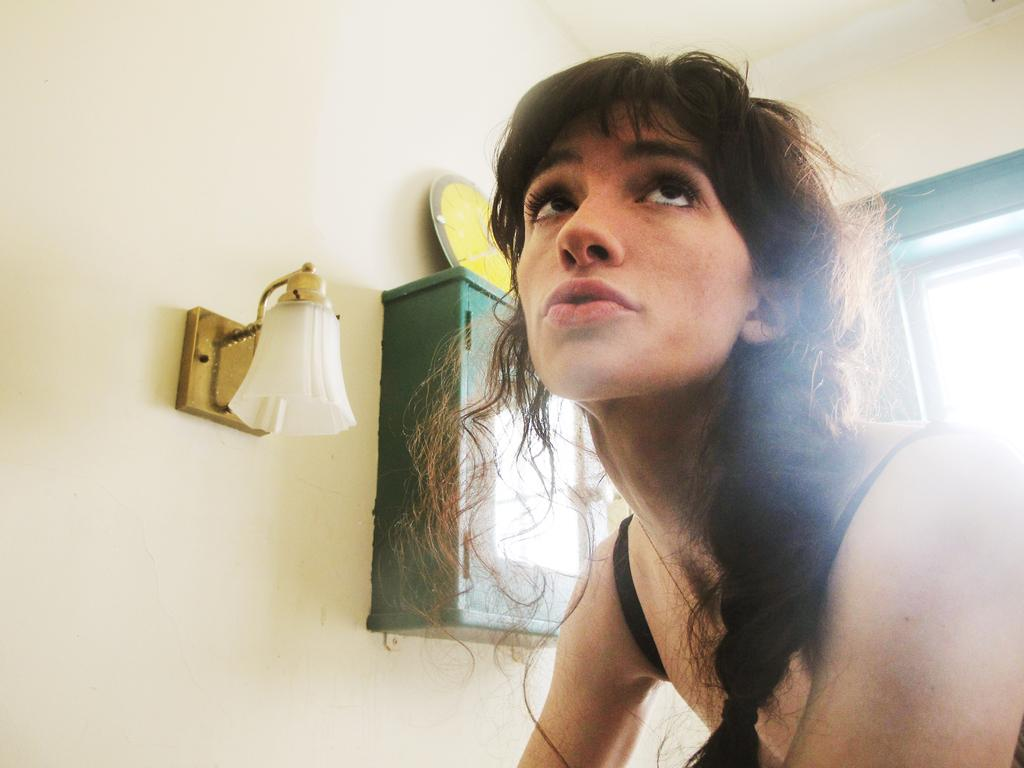What is the main subject of the image? There is a person in the image. What is the person doing in the image? The person is looking upwards. What objects can be seen on the wall in the image? There is a box and a lamp on the wall in the image. What time-related object is present in the image? There is a clock in the image. What architectural feature is visible in the image? There is a window in the image. What type of wine is the person holding in the image? There is no wine present in the image; the person is not holding any wine. How many rings does the person have on their fingers in the image? There is no mention of rings or any jewelry on the person's fingers in the image. 